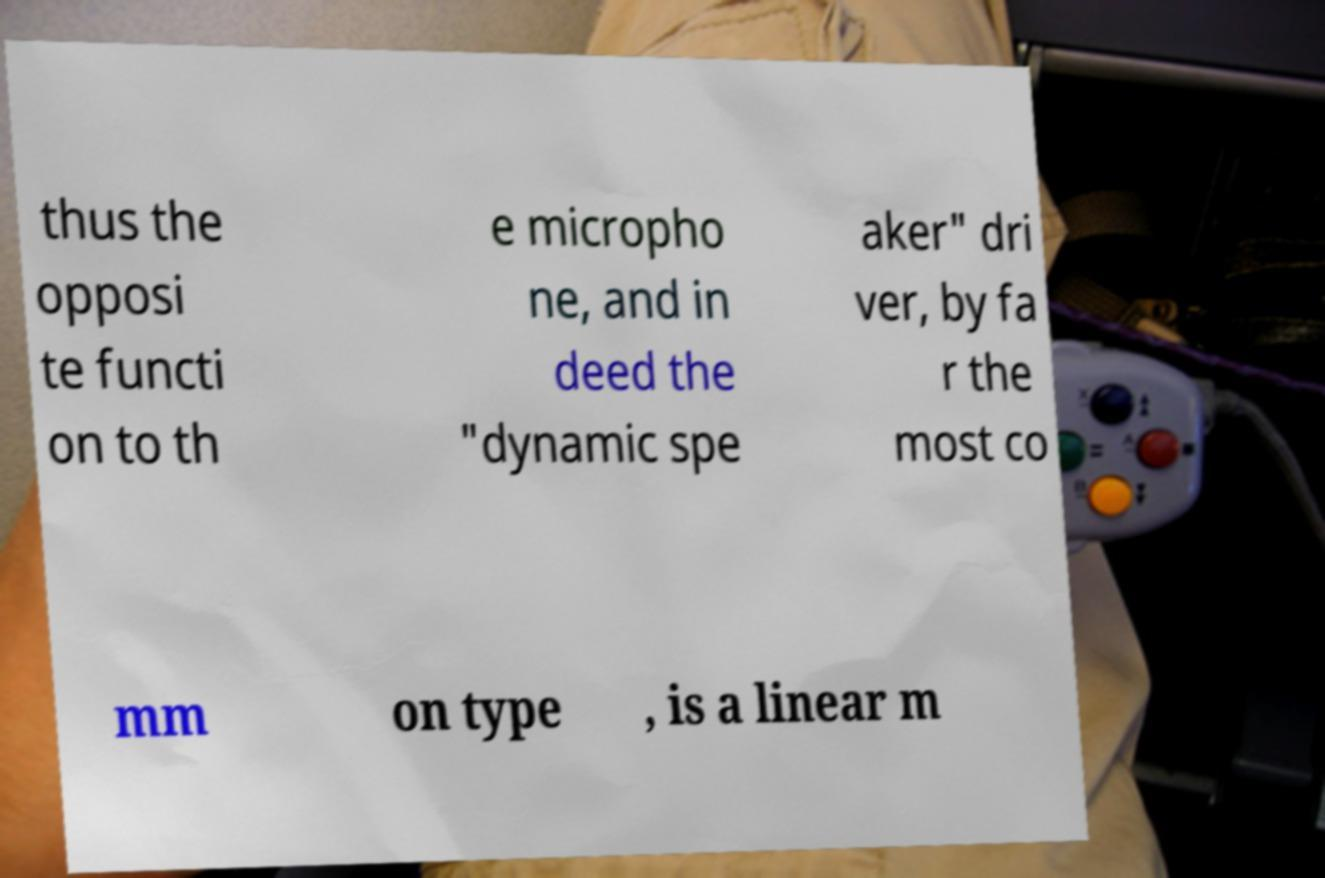Please read and relay the text visible in this image. What does it say? thus the opposi te functi on to th e micropho ne, and in deed the "dynamic spe aker" dri ver, by fa r the most co mm on type , is a linear m 